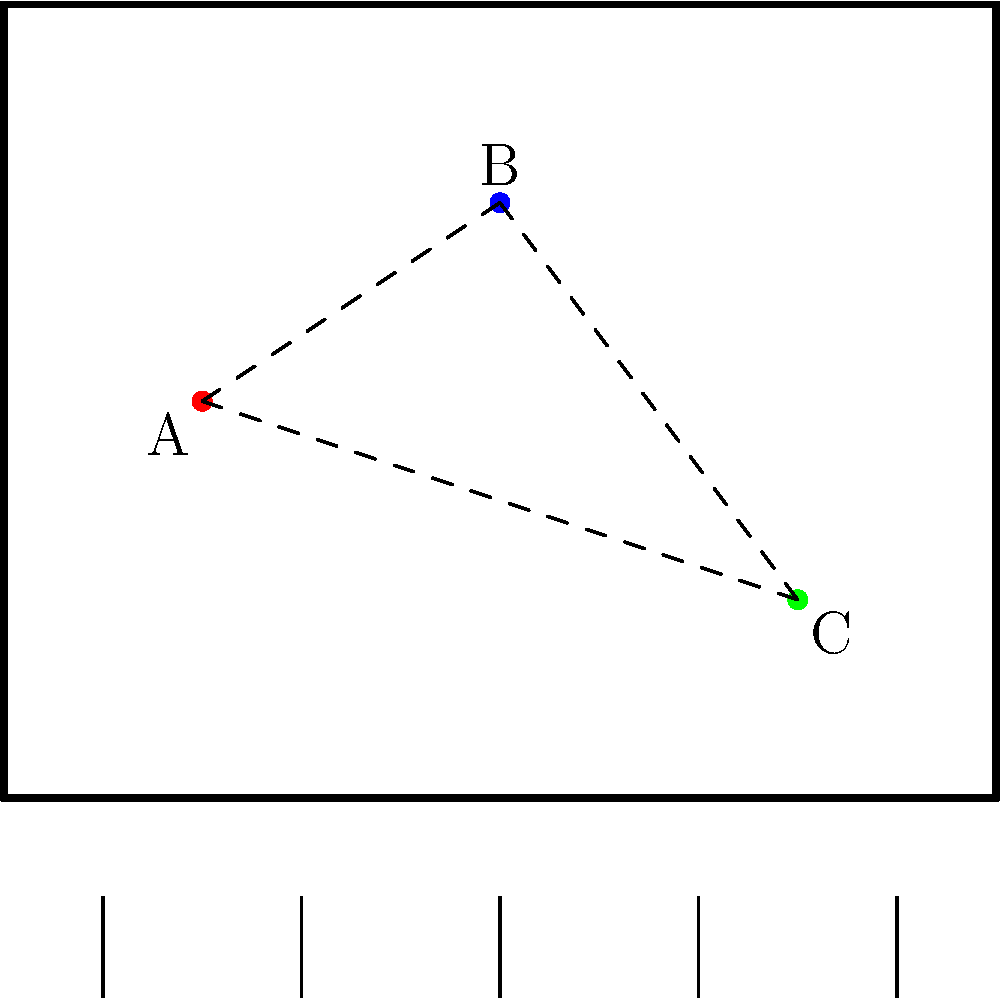In the stage blocking diagram above, three actors (A, B, and C) are positioned on stage. Considering the principles of stage composition and sight lines, which actor should be moved to create a more dynamic and visually balanced arrangement? To analyze this stage blocking diagram and determine which actor should be moved for a more dynamic and visually balanced arrangement, let's consider the following factors:

1. Triangular composition: The current arrangement forms a triangle, which is generally considered a strong composition. However, it's slightly imbalanced.

2. Stage areas: 
   - Actor A is downstage left
   - Actor B is upstage center
   - Actor C is center right

3. Sight lines: All actors have clear sight lines to each other, which is good for interaction.

4. Balance: The arrangement is slightly weighted towards stage right, with two actors (B and C) on that side.

5. Depth: There's good use of stage depth with actors placed upstage and downstage.

To improve the arrangement:

1. We should maintain the triangular composition but adjust it for better balance.
2. We need to redistribute the stage space more evenly.
3. We should keep clear sight lines between all actors.

The best choice would be to move Actor B. By moving B downstage right, we would:

1. Maintain the triangular composition
2. Create better balance across the stage
3. Utilize all areas of the stage more effectively (downstage left, upstage center, downstage right)
4. Maintain clear sight lines
5. Create a more dynamic arrangement with improved depth perception

This adjustment would result in a more visually balanced and dramatically interesting composition while maintaining the strengths of the original blocking.
Answer: Actor B should be moved downstage right. 